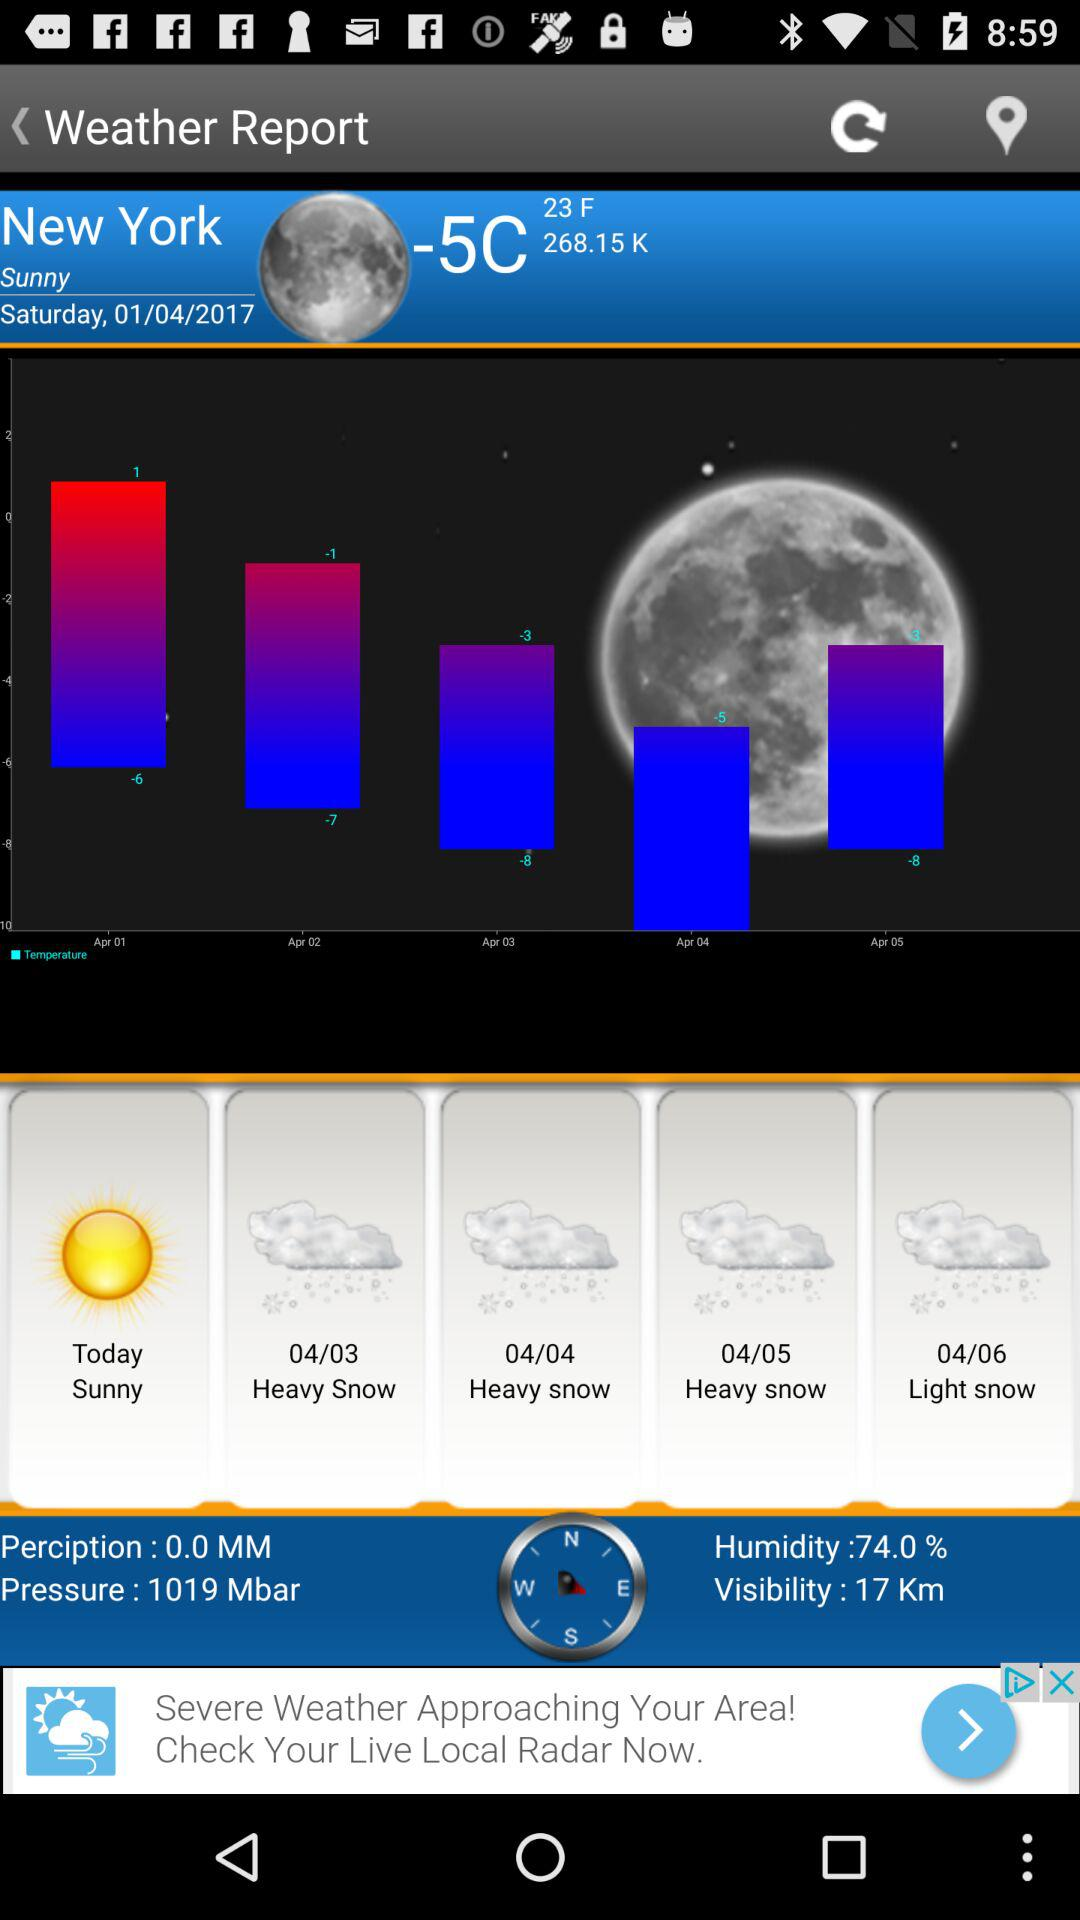What day is it today in New York? In New York, today is Saturday. 